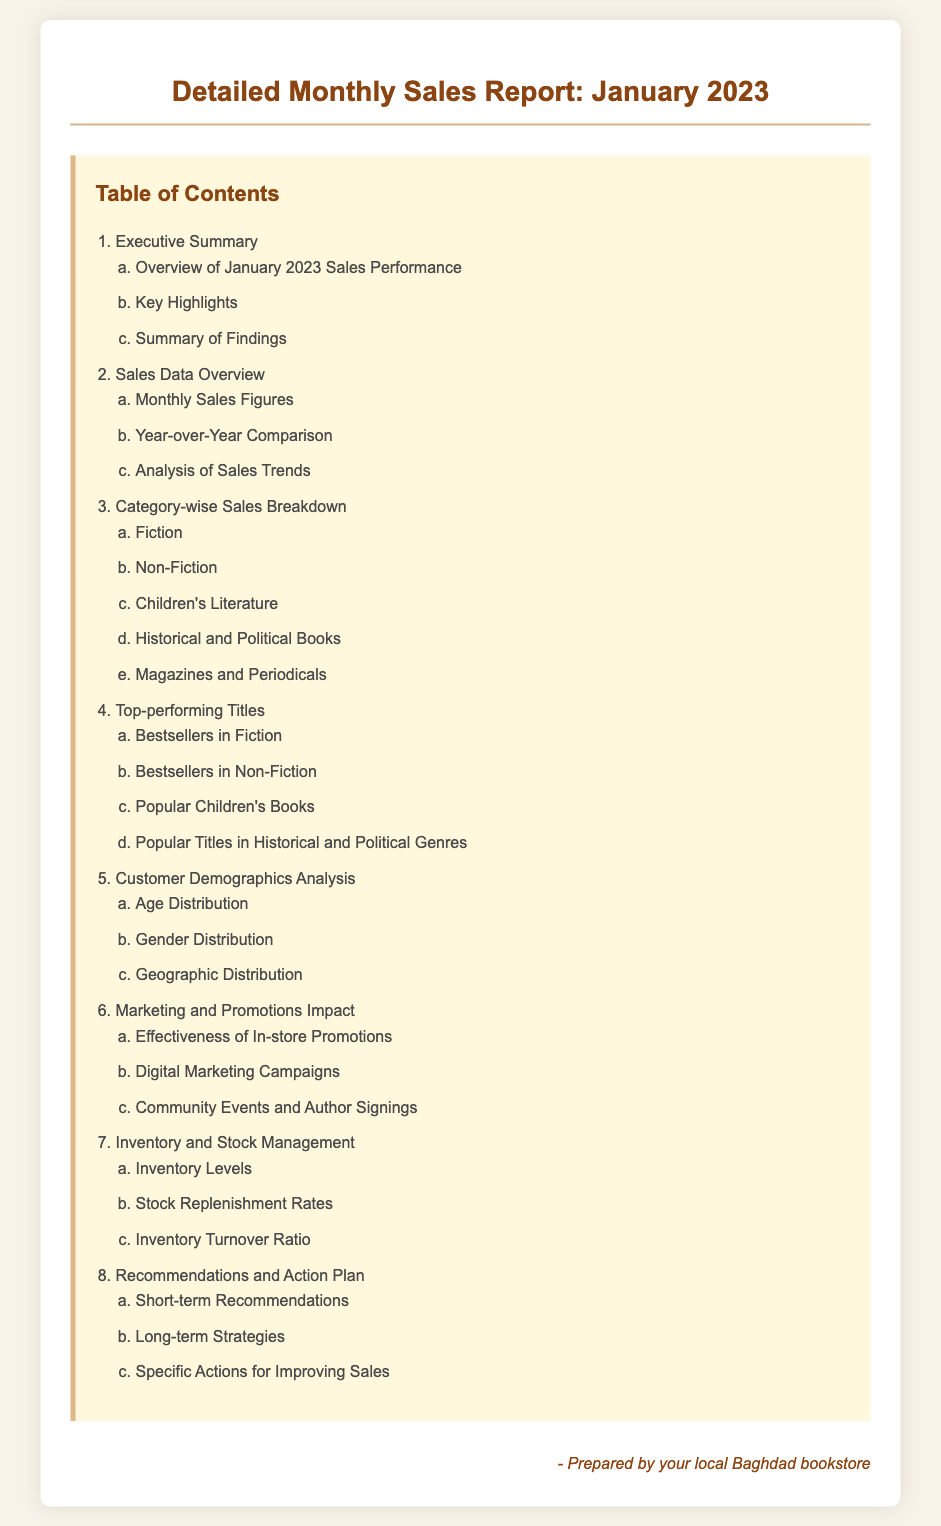what is the title of the document? The title is stated at the top and provides an overview of the content, which is "Detailed Monthly Sales Report: January 2023."
Answer: Detailed Monthly Sales Report: January 2023 how many sections are in the Table of Contents? The main sections in the Table of Contents are listed with numbers, totaling seven distinct sections.
Answer: 8 what is the first subsection under 'Executive Summary'? The first subsection provides insight into the sales performance for the mentioned period, specifically listed as "Overview of January 2023 Sales Performance."
Answer: Overview of January 2023 Sales Performance which category includes Children’s Literature? The document outlines category-wise sales breakdowns, and Children's Literature is one of those specified categories.
Answer: Children's Literature what are the demographics considered in the analysis? The document discusses various customer characteristics as part of the demographics, which includes age, gender, and geographic distribution.
Answer: Age, Gender, Geographic Distribution which section addresses the impact of marketing strategies? The performance of marketing strategies, including digital campaigns and promotions, is discussed in a section titled "Marketing and Promotions Impact."
Answer: Marketing and Promotions Impact how many top-performing title categories are listed? The document highlights specific categories of top-performing titles, mentioning four distinct segments under top-selling items.
Answer: 4 what does the last section of the document discuss? The final section focuses on actionable insights and future strategies for improving sales, titled "Recommendations and Action Plan."
Answer: Recommendations and Action Plan 